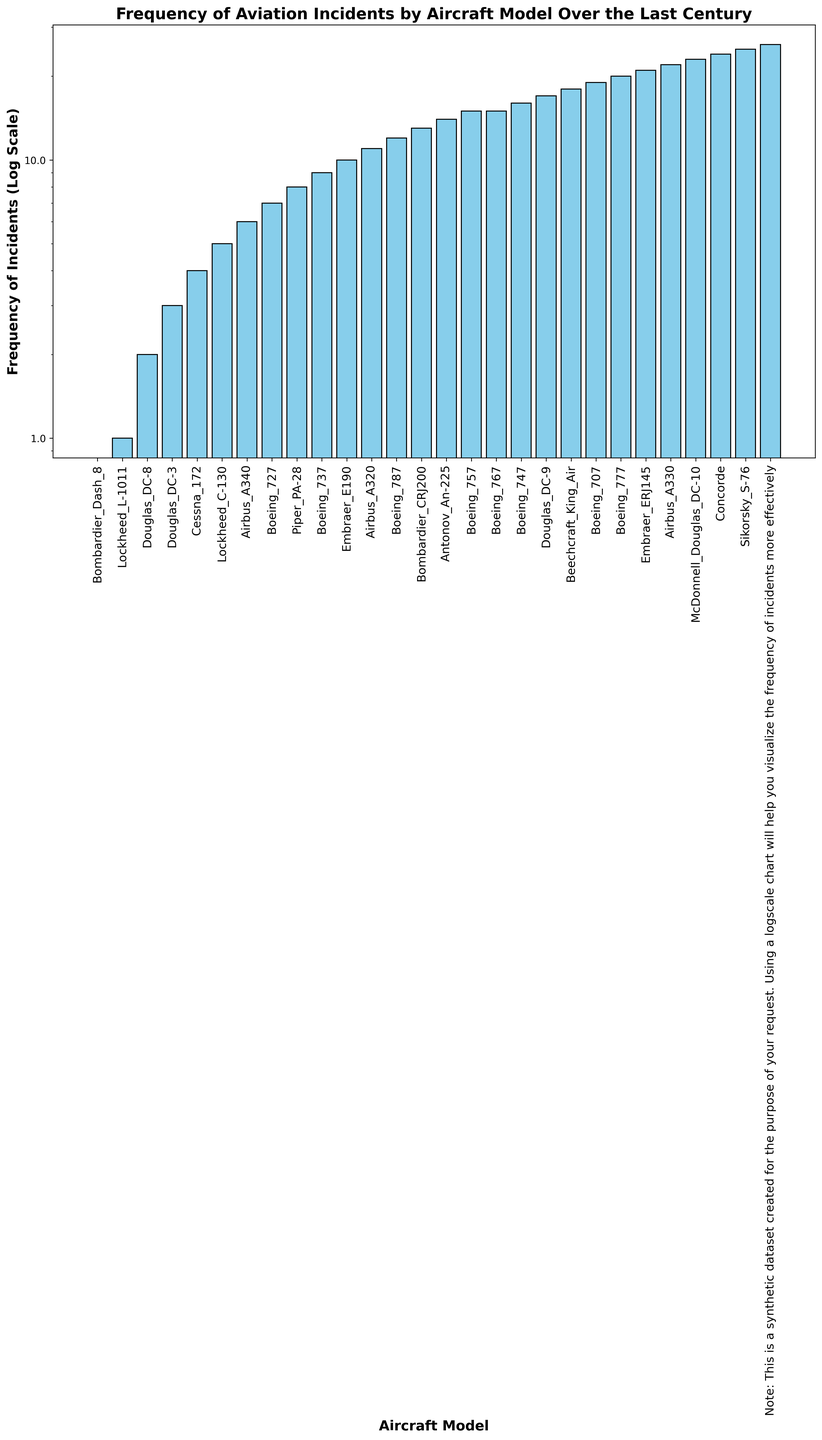what's the most frequent aircraft model in terms of incidents? The tallest bar in the bar chart represents the aircraft model with the highest frequency of incidents. The Boeing 737 has the highest bar.
Answer: Boeing 737 which aircraft models have fewer than 20 incidents? Looking at bars that fall below the 20 mark on the y-axis, we find Embraer_ERJ145, Concorde, Bombardier_Dash_8, Douglas_DC-8, Cessna_172, Lockheed_C-130, Piper_PA-28, Embraer_E190, Antonov_An-225, Beechcraft_King_Air, and Sikorsky_S-76.
Answer: Embraer_ERJ145, Concorde, Bombardier_Dash_8, Douglas_DC-8, Cessna_172, Lockheed_C-130, Piper_PA-28, Embraer_E190, Antonov_An-225, Beechcraft_King_Air, Sikorsky_S-76 how many models have an incident frequency higher than 100? Count the number of bars that reach beyond the 100 mark on the y-axis. There are six such bars: Boeing 737, Airbus A320, Boeing 747, Boeing 777, Airbus A330, McDonnell Douglas DC-10.
Answer: 6 does the frequency of incidents decrease steadily with each model? The bar lengths do decrease overall but not always steadily; there are some ups and downs between certain models. For example, the Boeing 777 has fewer incidents than the Boeing 747, and the Bombardier CRJ200 has fewer incidents than the Boeing 727 then rises again.
Answer: No are there more models with less than or equal to 10 incidents than those with more than 100? Count the models with less than or equal to 10 incidents (Concorde, Bombardier Dash 8, Douglas DC-8, Cessna 172, Lockheed C-130, Piper PA-28, Embraer E190, Antonov An-225, Beechcraft King Air, Sikorsky S-76) and those with more than 100 incidents (Boeing 737, Airbus A320, Boeing 747, Boeing 777, Airbus A330, McDonnell Douglas DC-10). There are 10 models with ≤10 incidents and 6 models with >100.
Answer: Yes what is the ratio of incidents between the Boeing 737 and the Airbus A340? The frequency of incidents for the Boeing 737 is 450 and for the Airbus A340 is 55. The ratio is 450/55.
Answer: 8.18 which model has a frequency closest to the median frequency value of the dataset? To determine the median, first sort frequencies: 1, 2, 3, 4, 5, 6, 7, 8, 9, 10, 12, 15, 20, 25, 25, 30, 35, 50, 55, 70, 85, 100, 115, 120, 210, 350, 450. The middle value is the 14th or 15th value, both being 25, for Boeing 757 and Boeing 767.
Answer: Boeing 757, Boeing 767 what can you infer about the relationship between aircraft age and incident frequency from the chart? Older models such as Douglas DC-3, Boeing 707, and Douglas DC-9 have lower frequencies, perhaps due to fewer active units or better safety records as aviation technology developed. Meanwhile, popular modern models like Boeing 737 and Airbus A320 have higher incident frequencies, potentially due to their widespread use.
Answer: Older models tend to have fewer incidents; popular modern models have more how does the incident frequency of the Douglas DC-3 compare to that of the Bombardier CRJ200? The bar for the Douglas DC-3 is visible with a frequency of 70, whereas the Bombardier CRJ200's bar shows a frequency of 30. The Douglas DC-3 has more incidents.
Answer: Douglas DC-3 has more what percentage of incidents involve models with more than 200 incidents? Sum incidents of models with >200 incidents (Boeing 737, Airbus A320, Boeing 747): 450 + 350 + 210 = 1010. Total incidents: sum of all frequencies, which is 1595. Percentage = (1010/1595) * 100.
Answer: Approx. 63.29% 